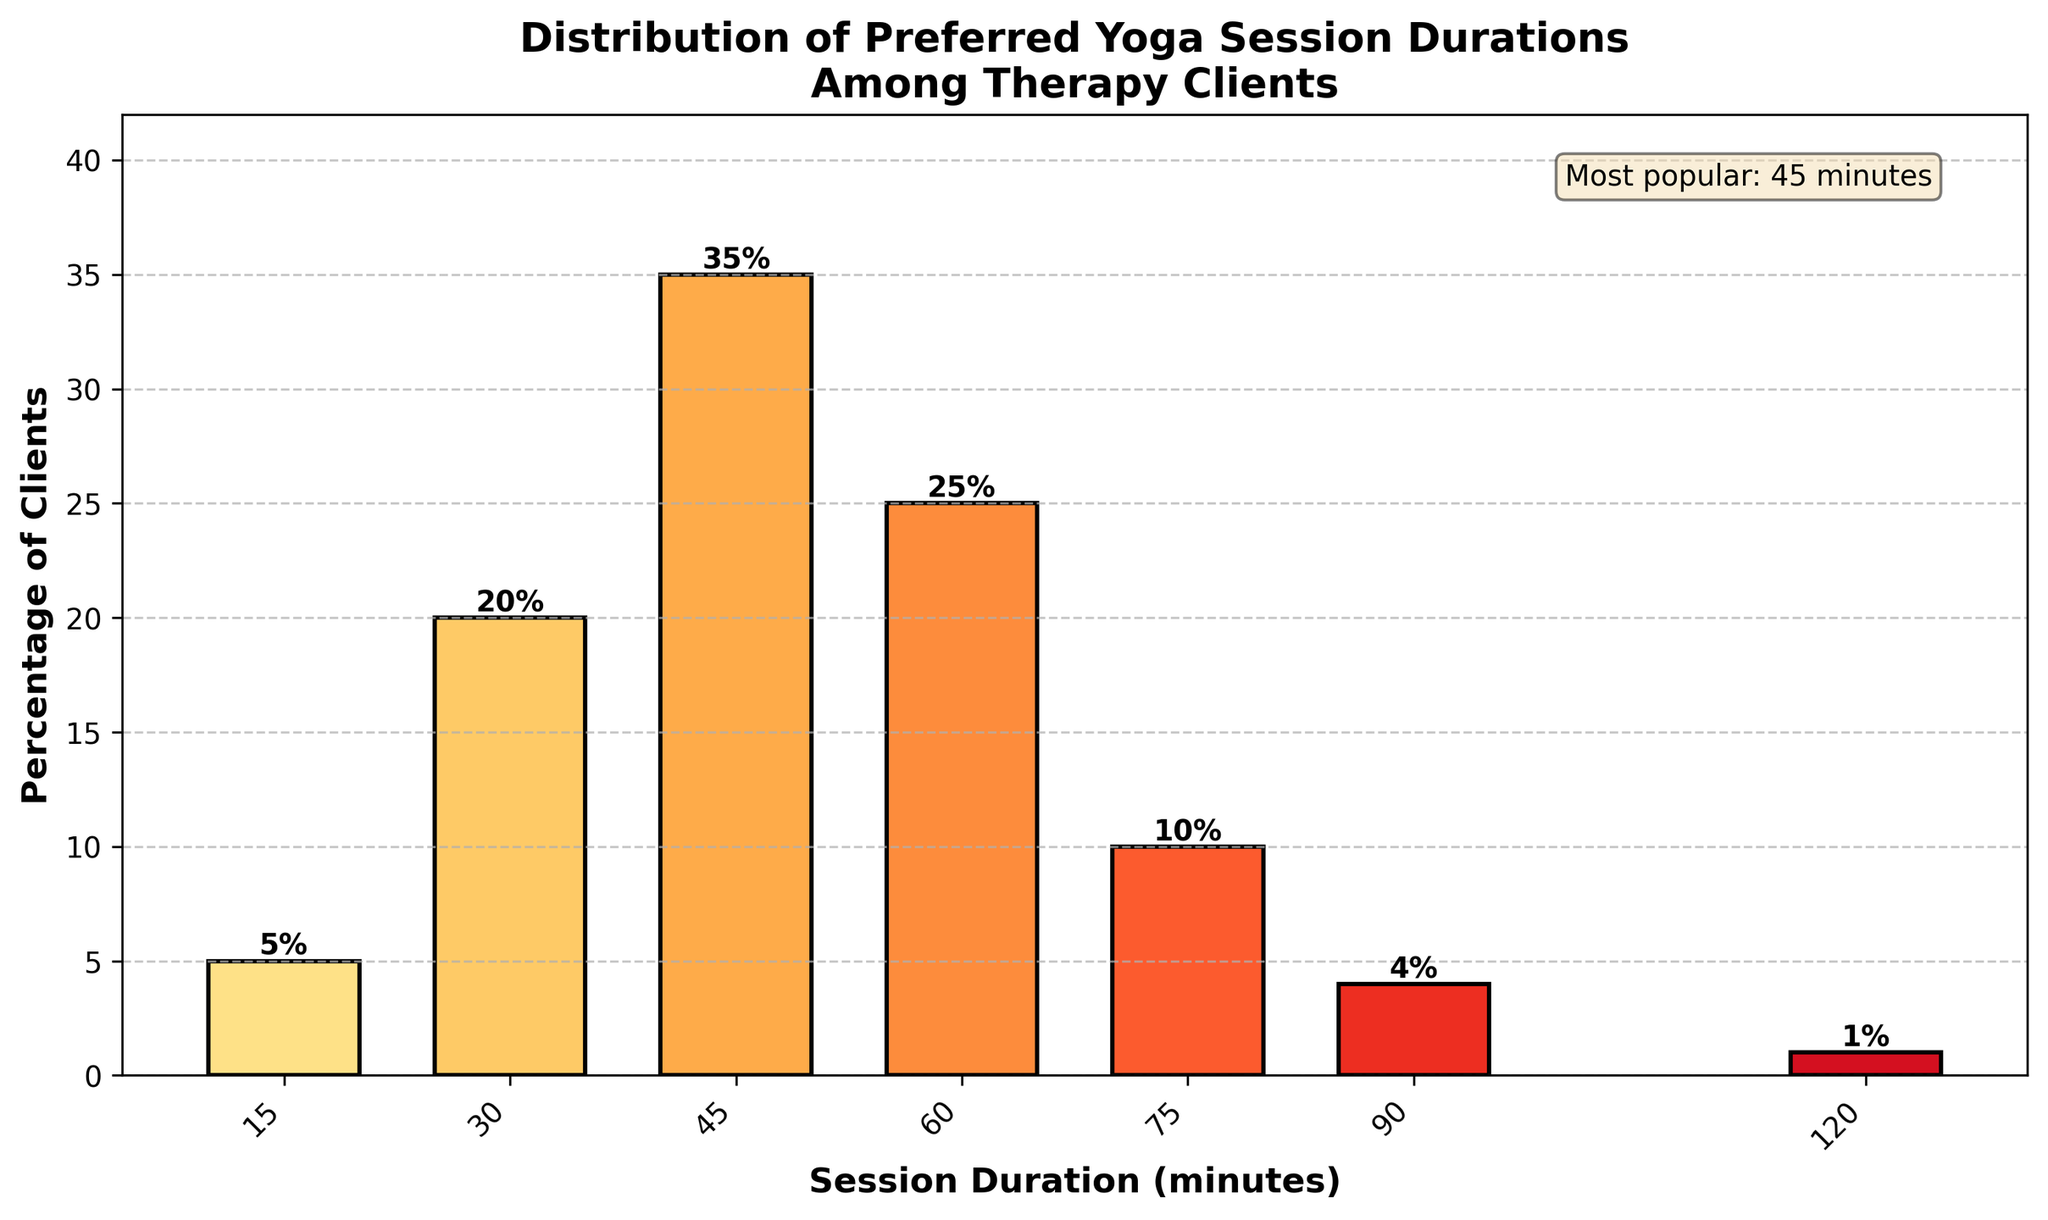How many clients prefer yoga sessions that last 45 minutes? The height of the bar representing the 45-minute duration shows a percentage of 35%. Since the data provides the percentage of clients, the actual number of clients is represented by the 35% figure.
Answer: 35% What is the difference in percentage between clients who prefer 60-minute sessions and those who prefer 30-minute sessions? By examining the heights of the bars, we see that 25% of clients prefer 60-minute sessions and 20% prefer 30-minute sessions. Subtracting these values gives us the difference: 25 - 20 = 5.
Answer: 5% Which session duration is preferred by the majority of clients? The tallest bar visually indicates the most preferred session duration. The 45-minute bar is the tallest one, representing 35% of clients.
Answer: 45 minutes What percentage of clients prefer sessions that are either 75 minutes or 90 minutes long? From the bar heights, 10% of clients prefer 75-minute sessions and 4% prefer 90-minute sessions. Adding these percentages together gives us: 10 + 4 = 14.
Answer: 14% How do the preferences for 120-minute sessions compare with those for 15-minute sessions? The bars for 120-minute and 15-minute sessions represent 1% and 5% respectively. 1% is less than 5%, so fewer clients prefer 120-minute sessions compared to 15-minute sessions.
Answer: Fewer clients prefer 120-minute sessions What is the combined percentage of clients who prefer session durations of 60 minutes or less? Summing up the percentages of clients who prefer 15, 30, 45, and 60-minute sessions: 5 + 20 + 35 + 25 = 85.
Answer: 85% Are more clients preferring 75-minute sessions or 120-minute sessions? From the heights of the bars, 10% of clients prefer 75-minute sessions and 1% prefer 120-minute sessions. Therefore, more clients prefer 75-minute sessions.
Answer: 75-minute sessions In which color range is the 60-minute session bar shaded? The 60-minute session bar is visually shaded with one of the middle to darker tones of the central yellow-to-orange-red gradient, indicating its positioning between 25% and 35%.
Answer: Yellow-to-orange-red range What is the total percentage of clients preferring sessions longer than 60 minutes? Adding the percentages of clients who prefer 75, 90, and 120-minute sessions gives us: 10 + 4 + 1 = 15.
Answer: 15% What session duration is indicated as the most popular in the text box on the figure? The text box in the figure mentions that the most popular session duration is 45 minutes.
Answer: 45 minutes 